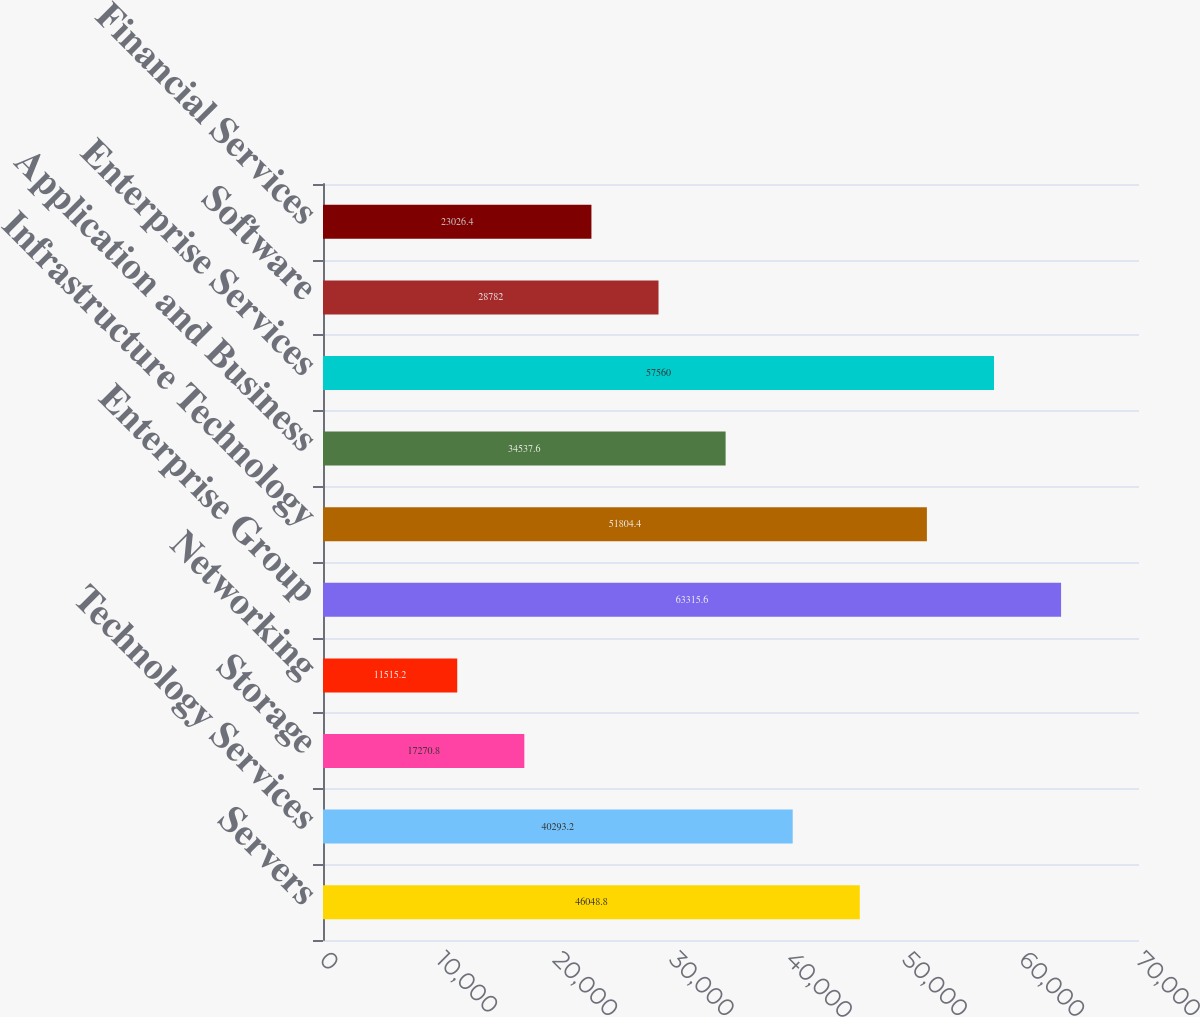Convert chart to OTSL. <chart><loc_0><loc_0><loc_500><loc_500><bar_chart><fcel>Servers<fcel>Technology Services<fcel>Storage<fcel>Networking<fcel>Enterprise Group<fcel>Infrastructure Technology<fcel>Application and Business<fcel>Enterprise Services<fcel>Software<fcel>Financial Services<nl><fcel>46048.8<fcel>40293.2<fcel>17270.8<fcel>11515.2<fcel>63315.6<fcel>51804.4<fcel>34537.6<fcel>57560<fcel>28782<fcel>23026.4<nl></chart> 